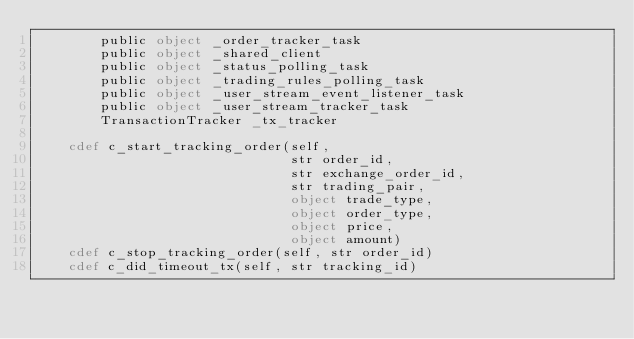<code> <loc_0><loc_0><loc_500><loc_500><_Cython_>        public object _order_tracker_task
        public object _shared_client
        public object _status_polling_task
        public object _trading_rules_polling_task
        public object _user_stream_event_listener_task
        public object _user_stream_tracker_task
        TransactionTracker _tx_tracker

    cdef c_start_tracking_order(self,
                                str order_id,
                                str exchange_order_id,
                                str trading_pair,
                                object trade_type,
                                object order_type,
                                object price,
                                object amount)
    cdef c_stop_tracking_order(self, str order_id)
    cdef c_did_timeout_tx(self, str tracking_id)
</code> 